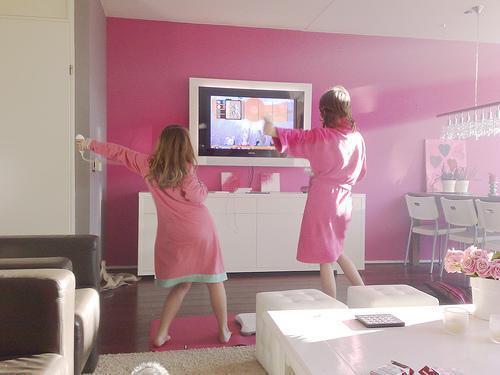How many couches?
Give a very brief answer. 2. How many couches are there?
Give a very brief answer. 2. How many people are visible?
Give a very brief answer. 2. 